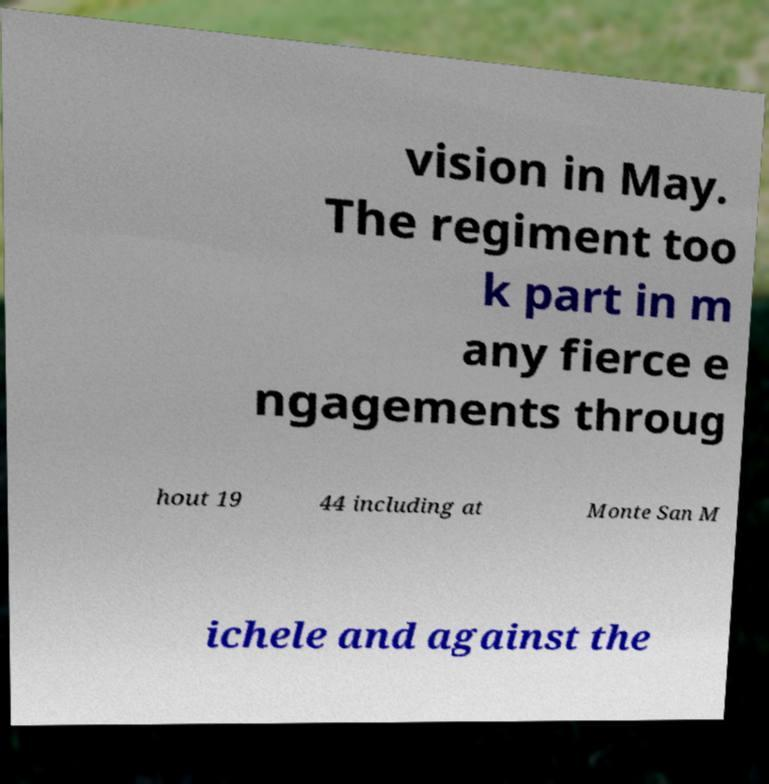Please identify and transcribe the text found in this image. vision in May. The regiment too k part in m any fierce e ngagements throug hout 19 44 including at Monte San M ichele and against the 